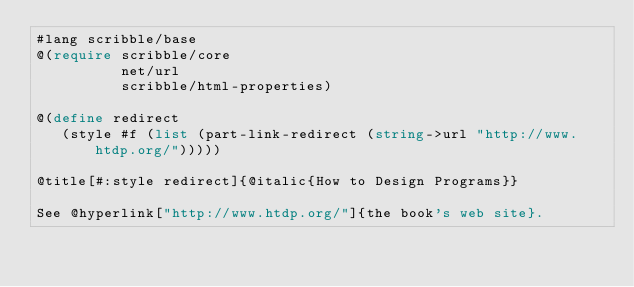Convert code to text. <code><loc_0><loc_0><loc_500><loc_500><_Racket_>#lang scribble/base
@(require scribble/core
          net/url
          scribble/html-properties)

@(define redirect
   (style #f (list (part-link-redirect (string->url "http://www.htdp.org/")))))

@title[#:style redirect]{@italic{How to Design Programs}}

See @hyperlink["http://www.htdp.org/"]{the book's web site}.
</code> 